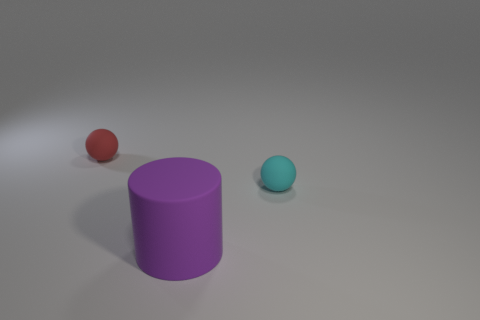Do the tiny object right of the tiny red sphere and the matte object that is in front of the tiny cyan thing have the same color?
Give a very brief answer. No. Are there any small gray metallic things?
Make the answer very short. No. Are there any small things made of the same material as the purple cylinder?
Your response must be concise. Yes. Are there any other things that are made of the same material as the purple object?
Provide a succinct answer. Yes. What is the color of the large cylinder?
Your answer should be compact. Purple. What color is the rubber sphere that is the same size as the cyan thing?
Give a very brief answer. Red. What number of metallic things are tiny spheres or tiny red objects?
Offer a very short reply. 0. How many balls are on the left side of the small cyan thing and in front of the small red matte ball?
Your answer should be very brief. 0. Is there any other thing that is the same shape as the purple thing?
Your answer should be compact. No. How many other objects are the same size as the purple object?
Offer a very short reply. 0. 